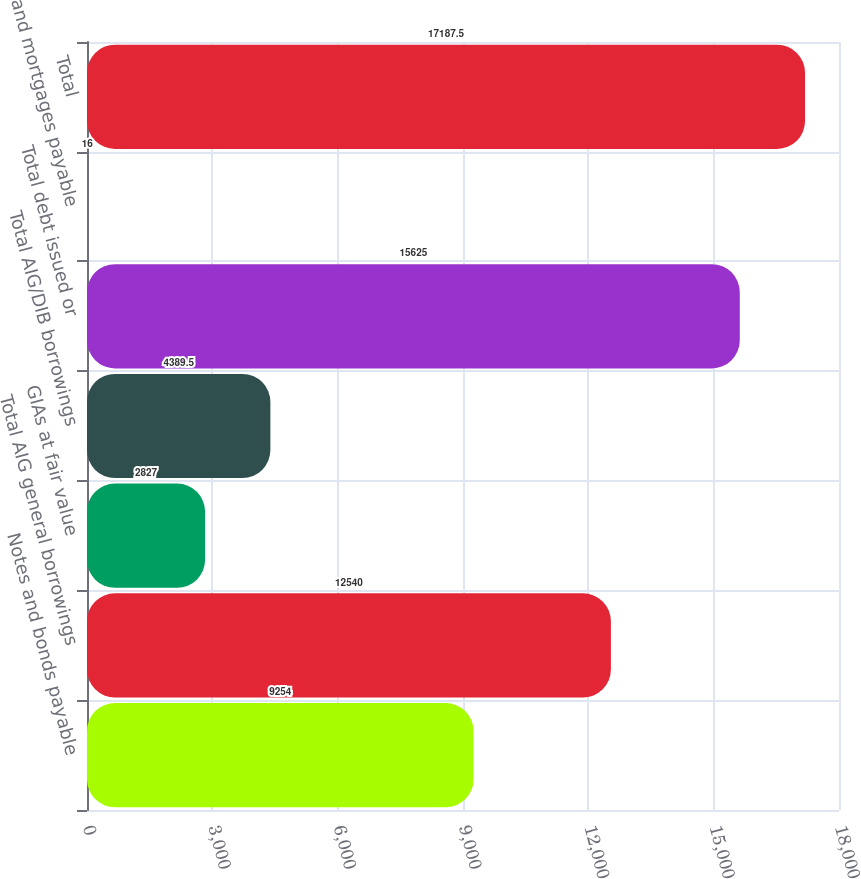<chart> <loc_0><loc_0><loc_500><loc_500><bar_chart><fcel>Notes and bonds payable<fcel>Total AIG general borrowings<fcel>GIAs at fair value<fcel>Total AIG/DIB borrowings<fcel>Total debt issued or<fcel>and mortgages payable<fcel>Total<nl><fcel>9254<fcel>12540<fcel>2827<fcel>4389.5<fcel>15625<fcel>16<fcel>17187.5<nl></chart> 